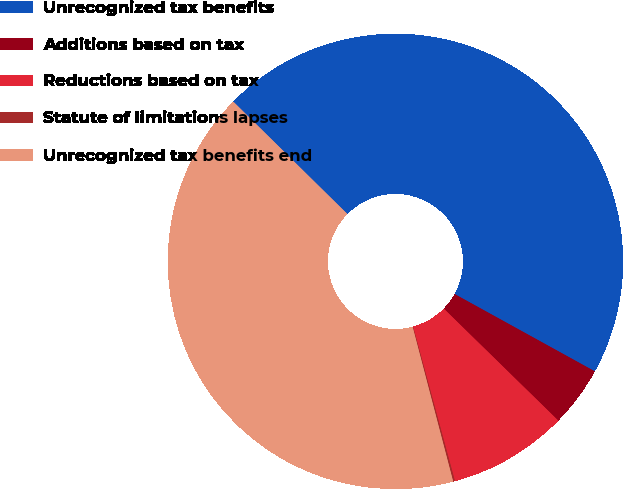Convert chart. <chart><loc_0><loc_0><loc_500><loc_500><pie_chart><fcel>Unrecognized tax benefits<fcel>Additions based on tax<fcel>Reductions based on tax<fcel>Statute of limitations lapses<fcel>Unrecognized tax benefits end<nl><fcel>45.64%<fcel>4.3%<fcel>8.47%<fcel>0.13%<fcel>41.47%<nl></chart> 